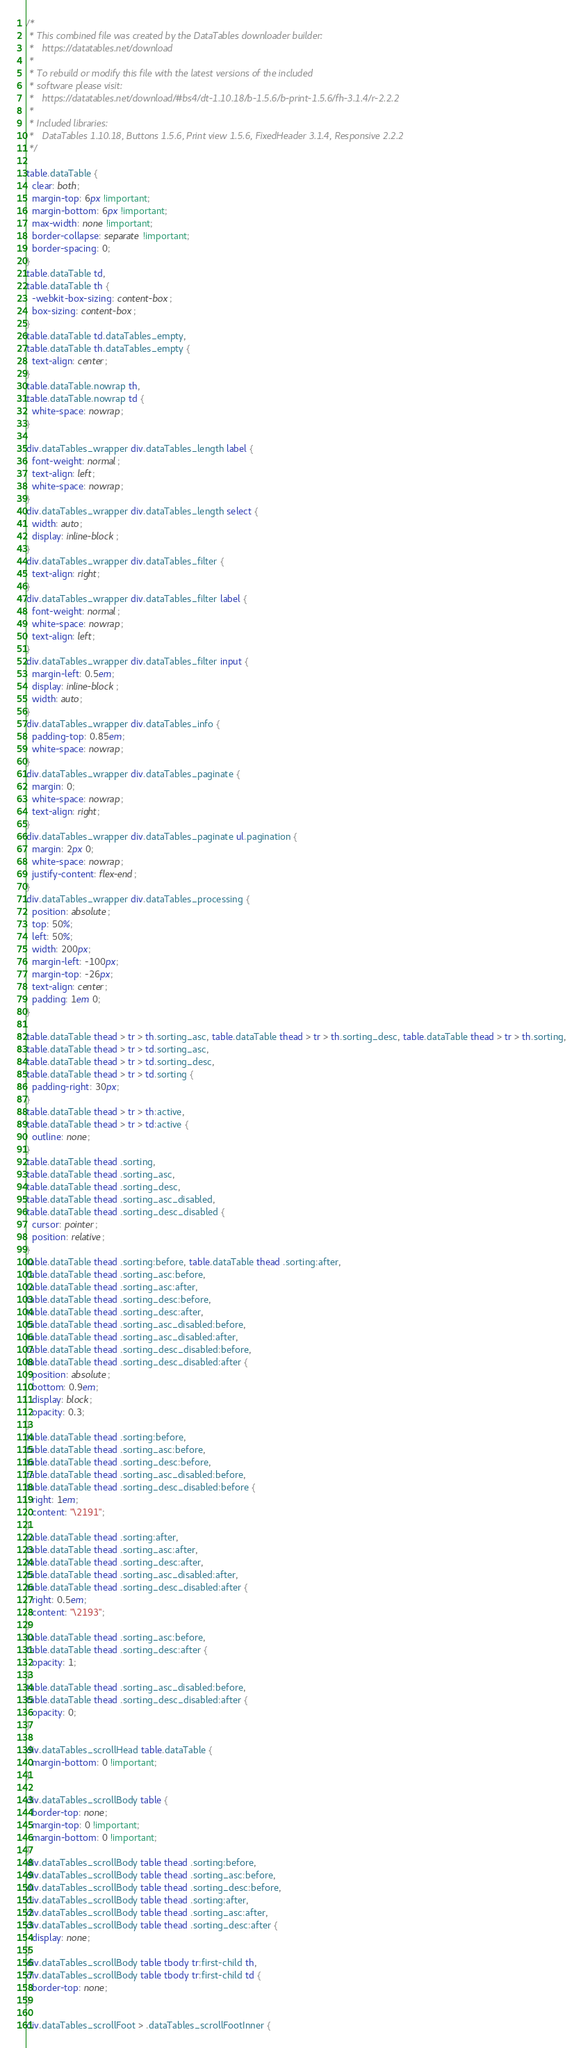<code> <loc_0><loc_0><loc_500><loc_500><_CSS_>/*
 * This combined file was created by the DataTables downloader builder:
 *   https://datatables.net/download
 *
 * To rebuild or modify this file with the latest versions of the included
 * software please visit:
 *   https://datatables.net/download/#bs4/dt-1.10.18/b-1.5.6/b-print-1.5.6/fh-3.1.4/r-2.2.2
 *
 * Included libraries:
 *   DataTables 1.10.18, Buttons 1.5.6, Print view 1.5.6, FixedHeader 3.1.4, Responsive 2.2.2
 */

table.dataTable {
  clear: both;
  margin-top: 6px !important;
  margin-bottom: 6px !important;
  max-width: none !important;
  border-collapse: separate !important;
  border-spacing: 0;
}
table.dataTable td,
table.dataTable th {
  -webkit-box-sizing: content-box;
  box-sizing: content-box;
}
table.dataTable td.dataTables_empty,
table.dataTable th.dataTables_empty {
  text-align: center;
}
table.dataTable.nowrap th,
table.dataTable.nowrap td {
  white-space: nowrap;
}

div.dataTables_wrapper div.dataTables_length label {
  font-weight: normal;
  text-align: left;
  white-space: nowrap;
}
div.dataTables_wrapper div.dataTables_length select {
  width: auto;
  display: inline-block;
}
div.dataTables_wrapper div.dataTables_filter {
  text-align: right;
}
div.dataTables_wrapper div.dataTables_filter label {
  font-weight: normal;
  white-space: nowrap;
  text-align: left;
}
div.dataTables_wrapper div.dataTables_filter input {
  margin-left: 0.5em;
  display: inline-block;
  width: auto;
}
div.dataTables_wrapper div.dataTables_info {
  padding-top: 0.85em;
  white-space: nowrap;
}
div.dataTables_wrapper div.dataTables_paginate {
  margin: 0;
  white-space: nowrap;
  text-align: right;
}
div.dataTables_wrapper div.dataTables_paginate ul.pagination {
  margin: 2px 0;
  white-space: nowrap;
  justify-content: flex-end;
}
div.dataTables_wrapper div.dataTables_processing {
  position: absolute;
  top: 50%;
  left: 50%;
  width: 200px;
  margin-left: -100px;
  margin-top: -26px;
  text-align: center;
  padding: 1em 0;
}

table.dataTable thead > tr > th.sorting_asc, table.dataTable thead > tr > th.sorting_desc, table.dataTable thead > tr > th.sorting,
table.dataTable thead > tr > td.sorting_asc,
table.dataTable thead > tr > td.sorting_desc,
table.dataTable thead > tr > td.sorting {
  padding-right: 30px;
}
table.dataTable thead > tr > th:active,
table.dataTable thead > tr > td:active {
  outline: none;
}
table.dataTable thead .sorting,
table.dataTable thead .sorting_asc,
table.dataTable thead .sorting_desc,
table.dataTable thead .sorting_asc_disabled,
table.dataTable thead .sorting_desc_disabled {
  cursor: pointer;
  position: relative;
}
table.dataTable thead .sorting:before, table.dataTable thead .sorting:after,
table.dataTable thead .sorting_asc:before,
table.dataTable thead .sorting_asc:after,
table.dataTable thead .sorting_desc:before,
table.dataTable thead .sorting_desc:after,
table.dataTable thead .sorting_asc_disabled:before,
table.dataTable thead .sorting_asc_disabled:after,
table.dataTable thead .sorting_desc_disabled:before,
table.dataTable thead .sorting_desc_disabled:after {
  position: absolute;
  bottom: 0.9em;
  display: block;
  opacity: 0.3;
}
table.dataTable thead .sorting:before,
table.dataTable thead .sorting_asc:before,
table.dataTable thead .sorting_desc:before,
table.dataTable thead .sorting_asc_disabled:before,
table.dataTable thead .sorting_desc_disabled:before {
  right: 1em;
  content: "\2191";
}
table.dataTable thead .sorting:after,
table.dataTable thead .sorting_asc:after,
table.dataTable thead .sorting_desc:after,
table.dataTable thead .sorting_asc_disabled:after,
table.dataTable thead .sorting_desc_disabled:after {
  right: 0.5em;
  content: "\2193";
}
table.dataTable thead .sorting_asc:before,
table.dataTable thead .sorting_desc:after {
  opacity: 1;
}
table.dataTable thead .sorting_asc_disabled:before,
table.dataTable thead .sorting_desc_disabled:after {
  opacity: 0;
}

div.dataTables_scrollHead table.dataTable {
  margin-bottom: 0 !important;
}

div.dataTables_scrollBody table {
  border-top: none;
  margin-top: 0 !important;
  margin-bottom: 0 !important;
}
div.dataTables_scrollBody table thead .sorting:before,
div.dataTables_scrollBody table thead .sorting_asc:before,
div.dataTables_scrollBody table thead .sorting_desc:before,
div.dataTables_scrollBody table thead .sorting:after,
div.dataTables_scrollBody table thead .sorting_asc:after,
div.dataTables_scrollBody table thead .sorting_desc:after {
  display: none;
}
div.dataTables_scrollBody table tbody tr:first-child th,
div.dataTables_scrollBody table tbody tr:first-child td {
  border-top: none;
}

div.dataTables_scrollFoot > .dataTables_scrollFootInner {</code> 